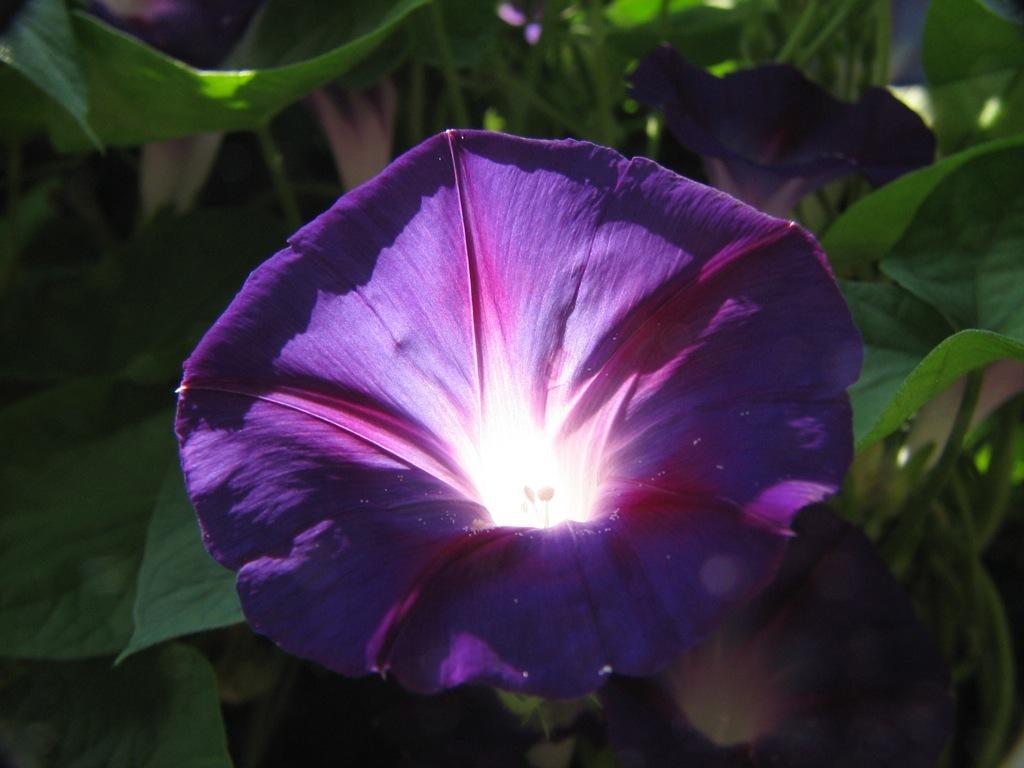What type of plants can be seen in the image? There are flowers and leaves in the image. Can you describe the appearance of the flowers? Unfortunately, the specific appearance of the flowers cannot be determined from the provided facts. What else is present in the image besides the flowers and leaves? No additional information is provided about other elements in the image. What breed of dog can be seen playing with the flowers in the image? There is no dog present in the image; it only features flowers and leaves. What type of skin condition is visible on the leaves in the image? There is no mention of any skin condition on the leaves in the image. 